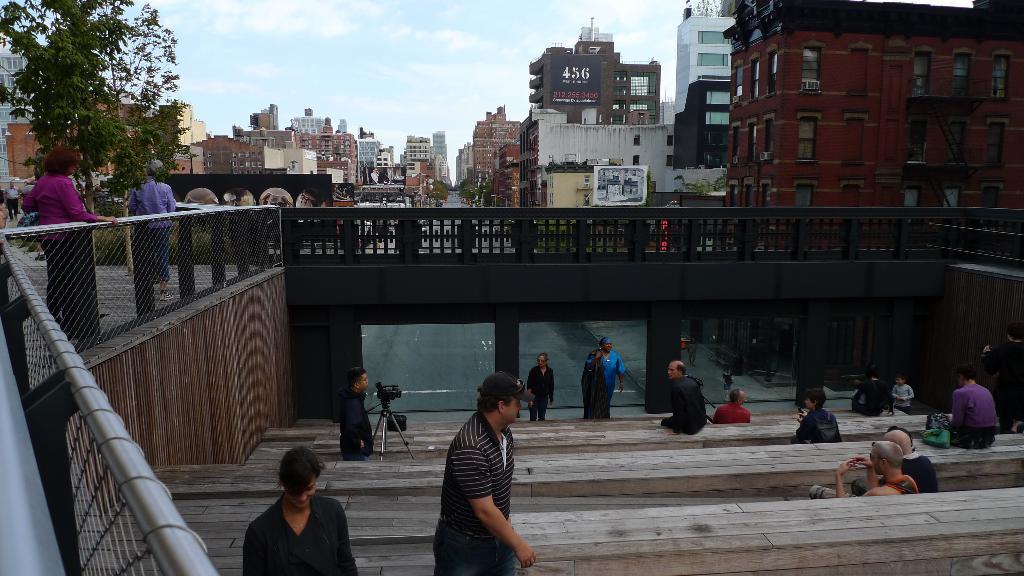Could you give a brief overview of what you see in this image? In this given picture there are steps under the bridge. On those steps there are some people sitting and some are coming upward from the steps. There is one guy who is standing in front of the camera on the steps. There is a bridge over the steps and there are three pillars visible here. There is a railing beside the bridge. There are two women standing here. There is a tree. There are some buildings behind the bridge. And in the background we can observe sky and clouds. 